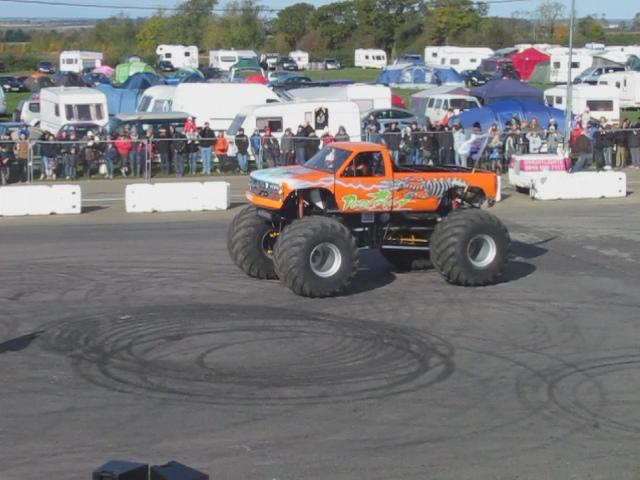What are the circular patterns on the ground? tire marks 